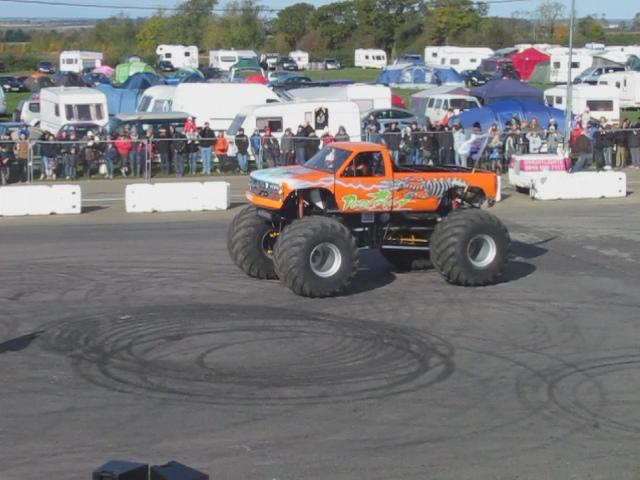What are the circular patterns on the ground? tire marks 